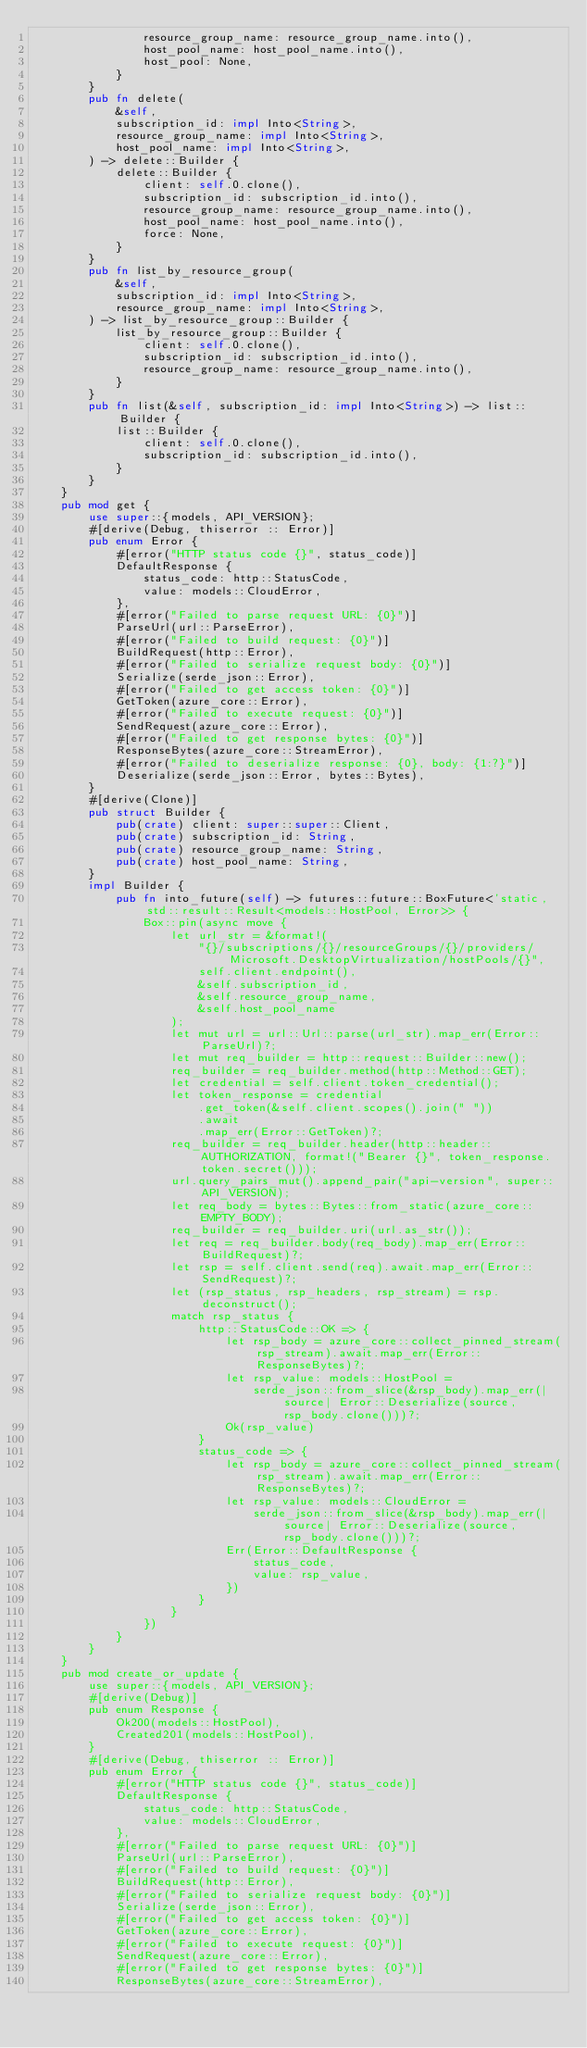<code> <loc_0><loc_0><loc_500><loc_500><_Rust_>                resource_group_name: resource_group_name.into(),
                host_pool_name: host_pool_name.into(),
                host_pool: None,
            }
        }
        pub fn delete(
            &self,
            subscription_id: impl Into<String>,
            resource_group_name: impl Into<String>,
            host_pool_name: impl Into<String>,
        ) -> delete::Builder {
            delete::Builder {
                client: self.0.clone(),
                subscription_id: subscription_id.into(),
                resource_group_name: resource_group_name.into(),
                host_pool_name: host_pool_name.into(),
                force: None,
            }
        }
        pub fn list_by_resource_group(
            &self,
            subscription_id: impl Into<String>,
            resource_group_name: impl Into<String>,
        ) -> list_by_resource_group::Builder {
            list_by_resource_group::Builder {
                client: self.0.clone(),
                subscription_id: subscription_id.into(),
                resource_group_name: resource_group_name.into(),
            }
        }
        pub fn list(&self, subscription_id: impl Into<String>) -> list::Builder {
            list::Builder {
                client: self.0.clone(),
                subscription_id: subscription_id.into(),
            }
        }
    }
    pub mod get {
        use super::{models, API_VERSION};
        #[derive(Debug, thiserror :: Error)]
        pub enum Error {
            #[error("HTTP status code {}", status_code)]
            DefaultResponse {
                status_code: http::StatusCode,
                value: models::CloudError,
            },
            #[error("Failed to parse request URL: {0}")]
            ParseUrl(url::ParseError),
            #[error("Failed to build request: {0}")]
            BuildRequest(http::Error),
            #[error("Failed to serialize request body: {0}")]
            Serialize(serde_json::Error),
            #[error("Failed to get access token: {0}")]
            GetToken(azure_core::Error),
            #[error("Failed to execute request: {0}")]
            SendRequest(azure_core::Error),
            #[error("Failed to get response bytes: {0}")]
            ResponseBytes(azure_core::StreamError),
            #[error("Failed to deserialize response: {0}, body: {1:?}")]
            Deserialize(serde_json::Error, bytes::Bytes),
        }
        #[derive(Clone)]
        pub struct Builder {
            pub(crate) client: super::super::Client,
            pub(crate) subscription_id: String,
            pub(crate) resource_group_name: String,
            pub(crate) host_pool_name: String,
        }
        impl Builder {
            pub fn into_future(self) -> futures::future::BoxFuture<'static, std::result::Result<models::HostPool, Error>> {
                Box::pin(async move {
                    let url_str = &format!(
                        "{}/subscriptions/{}/resourceGroups/{}/providers/Microsoft.DesktopVirtualization/hostPools/{}",
                        self.client.endpoint(),
                        &self.subscription_id,
                        &self.resource_group_name,
                        &self.host_pool_name
                    );
                    let mut url = url::Url::parse(url_str).map_err(Error::ParseUrl)?;
                    let mut req_builder = http::request::Builder::new();
                    req_builder = req_builder.method(http::Method::GET);
                    let credential = self.client.token_credential();
                    let token_response = credential
                        .get_token(&self.client.scopes().join(" "))
                        .await
                        .map_err(Error::GetToken)?;
                    req_builder = req_builder.header(http::header::AUTHORIZATION, format!("Bearer {}", token_response.token.secret()));
                    url.query_pairs_mut().append_pair("api-version", super::API_VERSION);
                    let req_body = bytes::Bytes::from_static(azure_core::EMPTY_BODY);
                    req_builder = req_builder.uri(url.as_str());
                    let req = req_builder.body(req_body).map_err(Error::BuildRequest)?;
                    let rsp = self.client.send(req).await.map_err(Error::SendRequest)?;
                    let (rsp_status, rsp_headers, rsp_stream) = rsp.deconstruct();
                    match rsp_status {
                        http::StatusCode::OK => {
                            let rsp_body = azure_core::collect_pinned_stream(rsp_stream).await.map_err(Error::ResponseBytes)?;
                            let rsp_value: models::HostPool =
                                serde_json::from_slice(&rsp_body).map_err(|source| Error::Deserialize(source, rsp_body.clone()))?;
                            Ok(rsp_value)
                        }
                        status_code => {
                            let rsp_body = azure_core::collect_pinned_stream(rsp_stream).await.map_err(Error::ResponseBytes)?;
                            let rsp_value: models::CloudError =
                                serde_json::from_slice(&rsp_body).map_err(|source| Error::Deserialize(source, rsp_body.clone()))?;
                            Err(Error::DefaultResponse {
                                status_code,
                                value: rsp_value,
                            })
                        }
                    }
                })
            }
        }
    }
    pub mod create_or_update {
        use super::{models, API_VERSION};
        #[derive(Debug)]
        pub enum Response {
            Ok200(models::HostPool),
            Created201(models::HostPool),
        }
        #[derive(Debug, thiserror :: Error)]
        pub enum Error {
            #[error("HTTP status code {}", status_code)]
            DefaultResponse {
                status_code: http::StatusCode,
                value: models::CloudError,
            },
            #[error("Failed to parse request URL: {0}")]
            ParseUrl(url::ParseError),
            #[error("Failed to build request: {0}")]
            BuildRequest(http::Error),
            #[error("Failed to serialize request body: {0}")]
            Serialize(serde_json::Error),
            #[error("Failed to get access token: {0}")]
            GetToken(azure_core::Error),
            #[error("Failed to execute request: {0}")]
            SendRequest(azure_core::Error),
            #[error("Failed to get response bytes: {0}")]
            ResponseBytes(azure_core::StreamError),</code> 